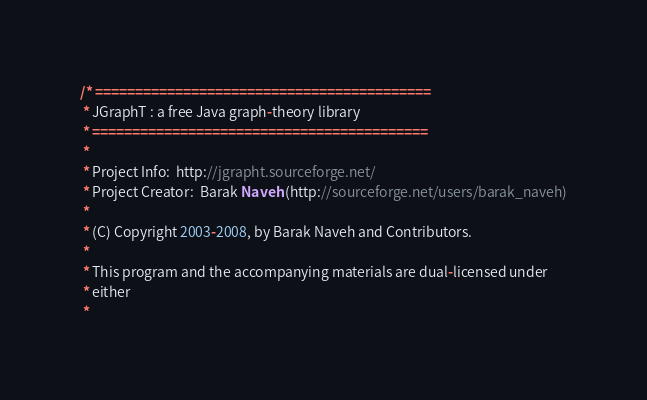Convert code to text. <code><loc_0><loc_0><loc_500><loc_500><_Java_>/* ==========================================
 * JGraphT : a free Java graph-theory library
 * ==========================================
 *
 * Project Info:  http://jgrapht.sourceforge.net/
 * Project Creator:  Barak Naveh (http://sourceforge.net/users/barak_naveh)
 *
 * (C) Copyright 2003-2008, by Barak Naveh and Contributors.
 *
 * This program and the accompanying materials are dual-licensed under
 * either
 *</code> 